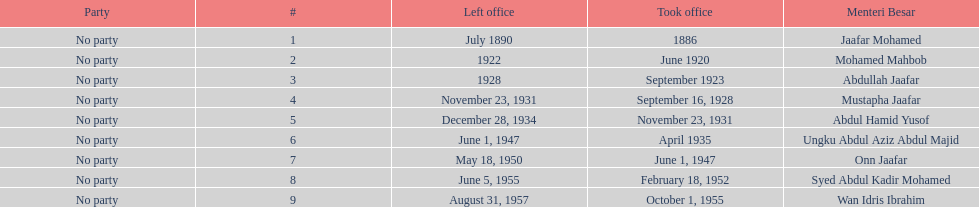I'm looking to parse the entire table for insights. Could you assist me with that? {'header': ['Party', '#', 'Left office', 'Took office', 'Menteri Besar'], 'rows': [['No party', '1', 'July 1890', '1886', 'Jaafar Mohamed'], ['No party', '2', '1922', 'June 1920', 'Mohamed Mahbob'], ['No party', '3', '1928', 'September 1923', 'Abdullah Jaafar'], ['No party', '4', 'November 23, 1931', 'September 16, 1928', 'Mustapha Jaafar'], ['No party', '5', 'December 28, 1934', 'November 23, 1931', 'Abdul Hamid Yusof'], ['No party', '6', 'June 1, 1947', 'April 1935', 'Ungku Abdul Aziz Abdul Majid'], ['No party', '7', 'May 18, 1950', 'June 1, 1947', 'Onn Jaafar'], ['No party', '8', 'June 5, 1955', 'February 18, 1952', 'Syed Abdul Kadir Mohamed'], ['No party', '9', 'August 31, 1957', 'October 1, 1955', 'Wan Idris Ibrahim']]} Other than abullah jaafar, name someone with the same last name. Mustapha Jaafar. 